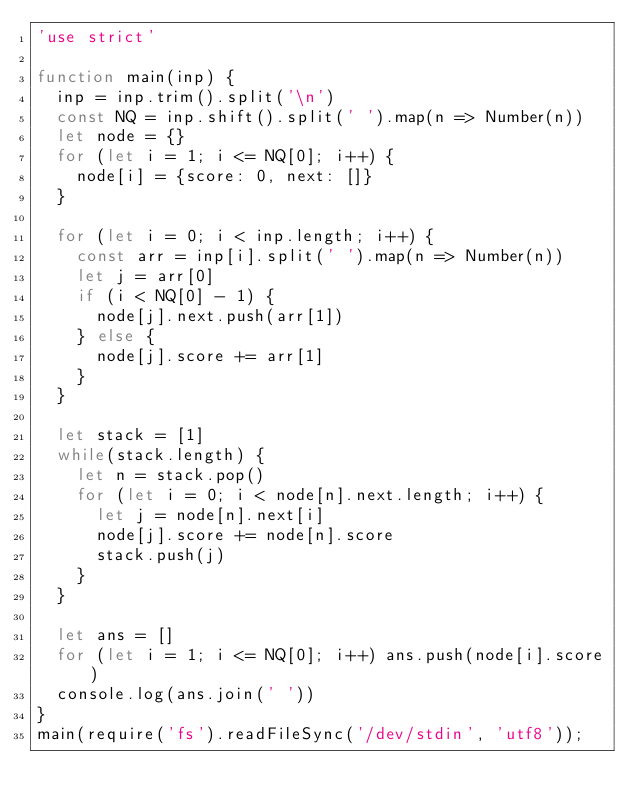<code> <loc_0><loc_0><loc_500><loc_500><_JavaScript_>'use strict'

function main(inp) {
  inp = inp.trim().split('\n')
  const NQ = inp.shift().split(' ').map(n => Number(n))
  let node = {}
  for (let i = 1; i <= NQ[0]; i++) {
    node[i] = {score: 0, next: []}
  }

  for (let i = 0; i < inp.length; i++) {
    const arr = inp[i].split(' ').map(n => Number(n))
    let j = arr[0]
    if (i < NQ[0] - 1) {
      node[j].next.push(arr[1])
    } else {
      node[j].score += arr[1]
    }
  }

  let stack = [1]
  while(stack.length) {
    let n = stack.pop()
    for (let i = 0; i < node[n].next.length; i++) {
      let j = node[n].next[i]
      node[j].score += node[n].score
      stack.push(j)
    }
  }
  
  let ans = []
  for (let i = 1; i <= NQ[0]; i++) ans.push(node[i].score)
  console.log(ans.join(' '))
}
main(require('fs').readFileSync('/dev/stdin', 'utf8'));
</code> 